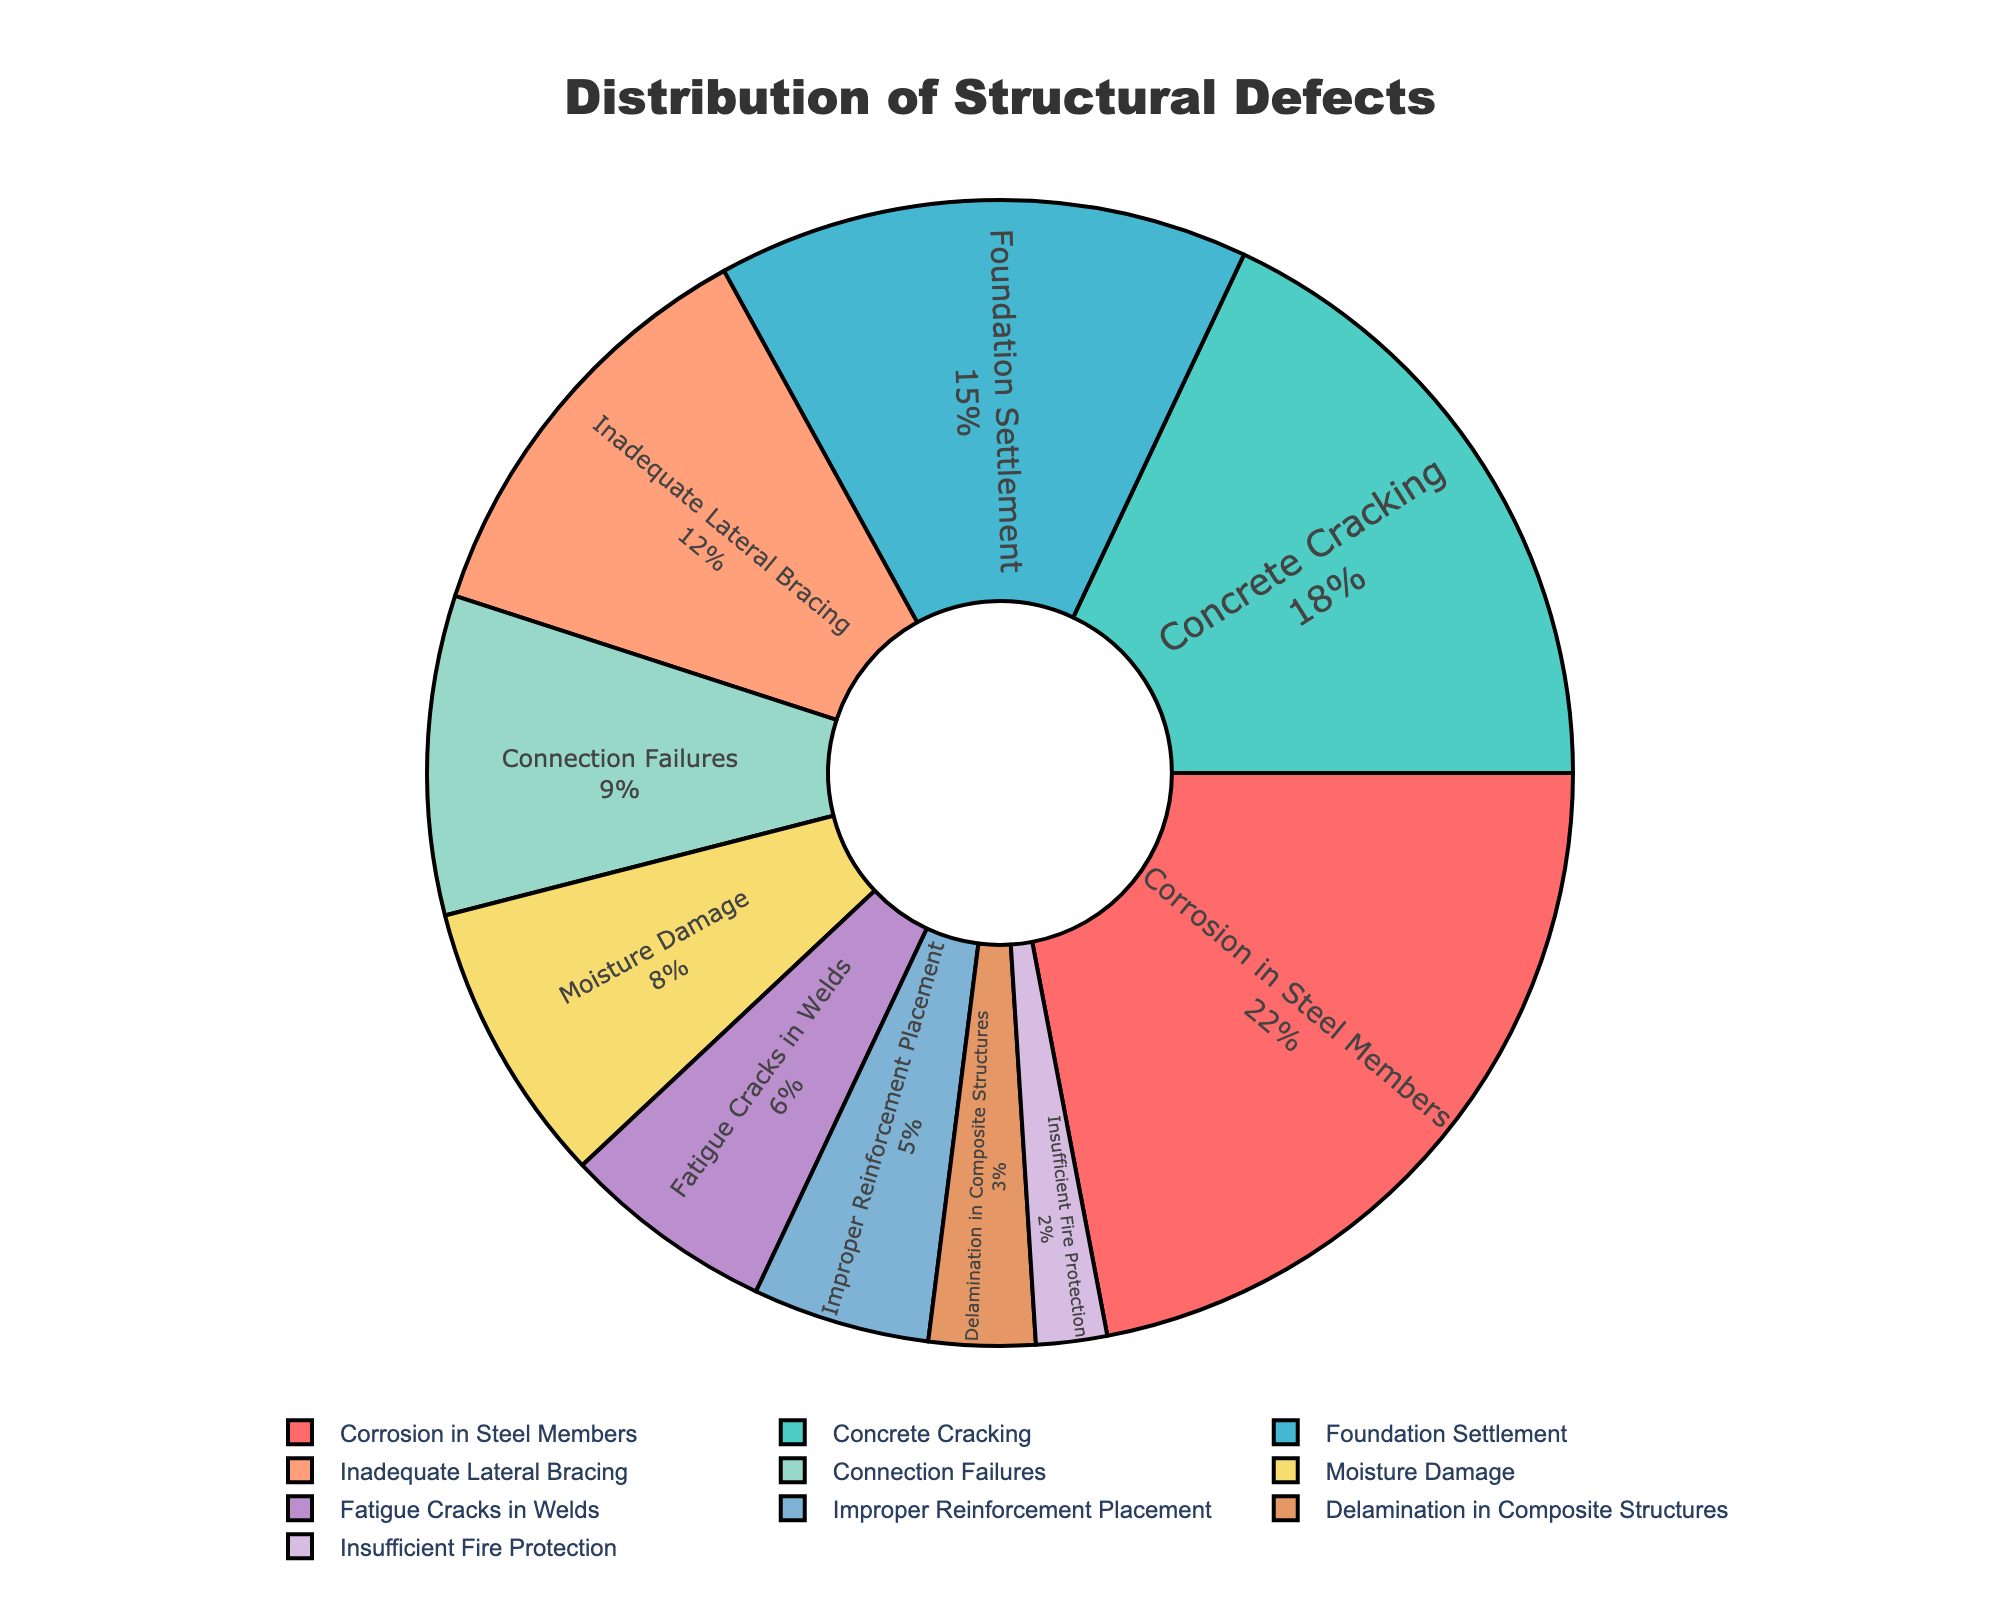What is the proportion of corrosion in steel members compared to concrete cracking? Corrosion in steel members accounts for 22% of the defects, while concrete cracking accounts for 18%. To find the proportion, divide the percentage of corrosion by that of concrete cracking: 22 / 18 ≈ 1.22.
Answer: 1.22 Which defect type has the highest percentage of occurrence? By looking at the pie chart, we can see that corrosion in steel members has the highest percentage with 22%.
Answer: Corrosion in Steel Members How does the percentage of foundation settlement compare to moisture damage? The percentage of foundation settlement is 15%, while moisture damage is 8%. Foundation settlement has almost double the percentage of moisture damage.
Answer: Foundation settlement is almost double moisture damage What is the difference in percentage between inadequate lateral bracing and fatigue cracks in welds? The percentage for inadequate lateral bracing is 12% and for fatigue cracks in welds is 6%. The difference is 12 - 6 = 6%.
Answer: 6% Which two defect types together make up approximately one-third of all defects? Adding the percentages for connection failures (9%) and moisture damage (8%), we get 9 + 8 = 17%. Adding another defect type, concrete cracking at 18%, the total becomes 35%. Hence, concrete cracking (18%) and another defect alone almost reach / surpass one-third of the defects.
Answer: Concrete Cracking and Moisture Damage How does improper reinforcement placement compare to insufficient fire protection in terms of percentage? Improper reinforcement placement accounts for 5% of the defects, whereas insufficient fire protection comprises 2%. Improper reinforcement placement is 3% more than insufficient fire protection.
Answer: Improper reinforcement placement is 3% more What is the sum of the percentages for the three least common defects? The three least common defects are improper reinforcement placement (5%), delamination in composite structures (3%), and insufficient fire protection (2%). Their sum is 5 + 3 + 2 = 10%.
Answer: 10% Which defects make up more than 50% of the total defects when combined? Adding the top defect categories: corrosion in steel members (22%), concrete cracking (18%), and foundation settlement (15%). Their combined percentage is 22 + 18 + 15 = 55%, which is more than 50%.
Answer: Corrosion in Steel Members, Concrete Cracking, and Foundation Settlement What is the total percentage contribution of the top three defect types? The top three defects are corrosion in steel members (22%), concrete cracking (18%), and foundation settlement (15%). The total is 22 + 18 + 15 = 55%.
Answer: 55% 